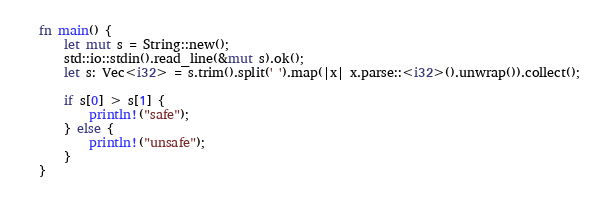<code> <loc_0><loc_0><loc_500><loc_500><_Rust_>fn main() {
    let mut s = String::new();
    std::io::stdin().read_line(&mut s).ok();
    let s: Vec<i32> = s.trim().split(' ').map(|x| x.parse::<i32>().unwrap()).collect();

    if s[0] > s[1] {
        println!("safe");
    } else {
        println!("unsafe");
    }
}</code> 